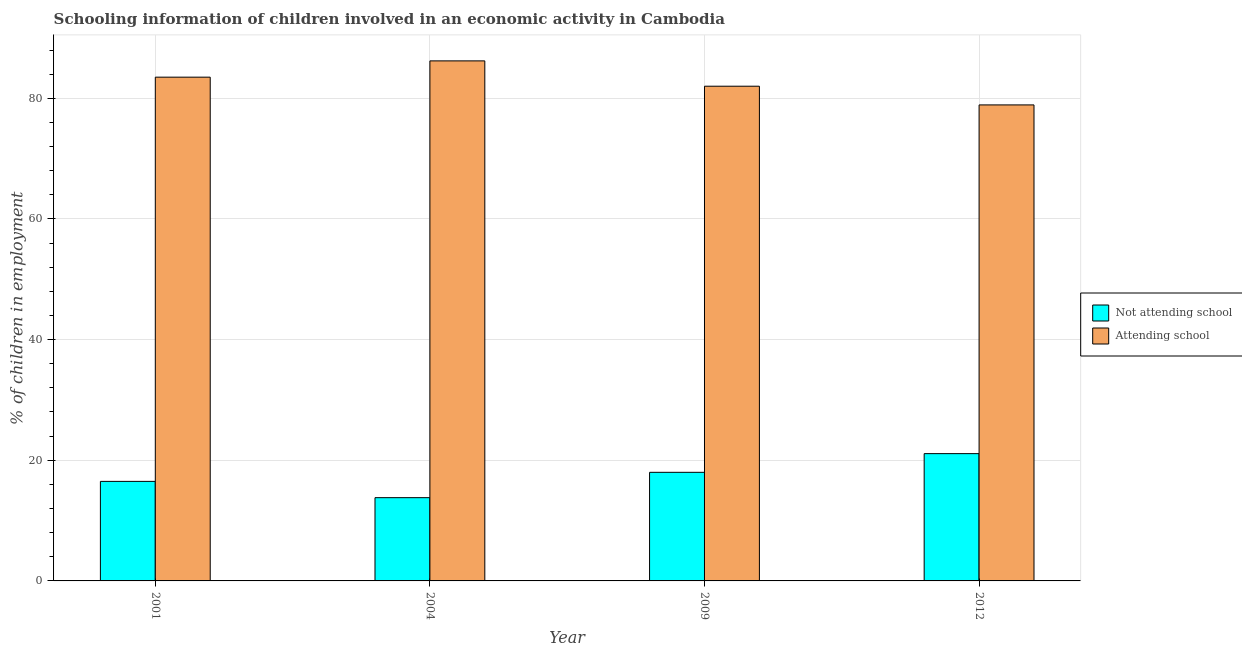How many groups of bars are there?
Make the answer very short. 4. Are the number of bars per tick equal to the number of legend labels?
Keep it short and to the point. Yes. Are the number of bars on each tick of the X-axis equal?
Give a very brief answer. Yes. What is the label of the 1st group of bars from the left?
Your response must be concise. 2001. In how many cases, is the number of bars for a given year not equal to the number of legend labels?
Your answer should be very brief. 0. What is the percentage of employed children who are not attending school in 2004?
Offer a very short reply. 13.8. Across all years, what is the maximum percentage of employed children who are attending school?
Your answer should be compact. 86.2. Across all years, what is the minimum percentage of employed children who are not attending school?
Your response must be concise. 13.8. In which year was the percentage of employed children who are attending school minimum?
Give a very brief answer. 2012. What is the total percentage of employed children who are not attending school in the graph?
Your answer should be compact. 69.4. What is the difference between the percentage of employed children who are attending school in 2001 and that in 2004?
Provide a succinct answer. -2.7. What is the difference between the percentage of employed children who are not attending school in 2001 and the percentage of employed children who are attending school in 2004?
Keep it short and to the point. 2.7. What is the average percentage of employed children who are attending school per year?
Your response must be concise. 82.65. In the year 2009, what is the difference between the percentage of employed children who are attending school and percentage of employed children who are not attending school?
Make the answer very short. 0. What is the ratio of the percentage of employed children who are not attending school in 2009 to that in 2012?
Offer a very short reply. 0.85. Is the difference between the percentage of employed children who are not attending school in 2004 and 2012 greater than the difference between the percentage of employed children who are attending school in 2004 and 2012?
Provide a short and direct response. No. What is the difference between the highest and the second highest percentage of employed children who are attending school?
Your answer should be compact. 2.7. What is the difference between the highest and the lowest percentage of employed children who are not attending school?
Your response must be concise. 7.3. In how many years, is the percentage of employed children who are attending school greater than the average percentage of employed children who are attending school taken over all years?
Your answer should be compact. 2. Is the sum of the percentage of employed children who are not attending school in 2001 and 2012 greater than the maximum percentage of employed children who are attending school across all years?
Provide a succinct answer. Yes. What does the 2nd bar from the left in 2001 represents?
Ensure brevity in your answer.  Attending school. What does the 2nd bar from the right in 2009 represents?
Your answer should be compact. Not attending school. How many bars are there?
Your answer should be very brief. 8. What is the difference between two consecutive major ticks on the Y-axis?
Your response must be concise. 20. Are the values on the major ticks of Y-axis written in scientific E-notation?
Your response must be concise. No. Does the graph contain any zero values?
Your answer should be compact. No. How many legend labels are there?
Give a very brief answer. 2. How are the legend labels stacked?
Provide a succinct answer. Vertical. What is the title of the graph?
Offer a very short reply. Schooling information of children involved in an economic activity in Cambodia. What is the label or title of the Y-axis?
Give a very brief answer. % of children in employment. What is the % of children in employment of Not attending school in 2001?
Your response must be concise. 16.5. What is the % of children in employment in Attending school in 2001?
Your answer should be compact. 83.5. What is the % of children in employment of Attending school in 2004?
Offer a very short reply. 86.2. What is the % of children in employment in Attending school in 2009?
Keep it short and to the point. 82. What is the % of children in employment of Not attending school in 2012?
Keep it short and to the point. 21.1. What is the % of children in employment of Attending school in 2012?
Your answer should be compact. 78.9. Across all years, what is the maximum % of children in employment in Not attending school?
Make the answer very short. 21.1. Across all years, what is the maximum % of children in employment of Attending school?
Offer a terse response. 86.2. Across all years, what is the minimum % of children in employment in Attending school?
Offer a very short reply. 78.9. What is the total % of children in employment in Not attending school in the graph?
Your response must be concise. 69.4. What is the total % of children in employment of Attending school in the graph?
Keep it short and to the point. 330.6. What is the difference between the % of children in employment of Not attending school in 2001 and that in 2004?
Provide a succinct answer. 2.7. What is the difference between the % of children in employment of Attending school in 2001 and that in 2004?
Your answer should be compact. -2.7. What is the difference between the % of children in employment in Not attending school in 2001 and that in 2009?
Provide a succinct answer. -1.5. What is the difference between the % of children in employment of Not attending school in 2001 and that in 2012?
Keep it short and to the point. -4.6. What is the difference between the % of children in employment in Attending school in 2004 and that in 2009?
Keep it short and to the point. 4.2. What is the difference between the % of children in employment of Not attending school in 2004 and that in 2012?
Your answer should be compact. -7.3. What is the difference between the % of children in employment of Not attending school in 2001 and the % of children in employment of Attending school in 2004?
Provide a succinct answer. -69.7. What is the difference between the % of children in employment in Not attending school in 2001 and the % of children in employment in Attending school in 2009?
Make the answer very short. -65.5. What is the difference between the % of children in employment of Not attending school in 2001 and the % of children in employment of Attending school in 2012?
Your answer should be very brief. -62.4. What is the difference between the % of children in employment in Not attending school in 2004 and the % of children in employment in Attending school in 2009?
Your answer should be very brief. -68.2. What is the difference between the % of children in employment in Not attending school in 2004 and the % of children in employment in Attending school in 2012?
Provide a succinct answer. -65.1. What is the difference between the % of children in employment in Not attending school in 2009 and the % of children in employment in Attending school in 2012?
Offer a very short reply. -60.9. What is the average % of children in employment in Not attending school per year?
Ensure brevity in your answer.  17.35. What is the average % of children in employment of Attending school per year?
Ensure brevity in your answer.  82.65. In the year 2001, what is the difference between the % of children in employment in Not attending school and % of children in employment in Attending school?
Your answer should be very brief. -67. In the year 2004, what is the difference between the % of children in employment of Not attending school and % of children in employment of Attending school?
Make the answer very short. -72.4. In the year 2009, what is the difference between the % of children in employment in Not attending school and % of children in employment in Attending school?
Keep it short and to the point. -64. In the year 2012, what is the difference between the % of children in employment of Not attending school and % of children in employment of Attending school?
Offer a very short reply. -57.8. What is the ratio of the % of children in employment in Not attending school in 2001 to that in 2004?
Offer a very short reply. 1.2. What is the ratio of the % of children in employment of Attending school in 2001 to that in 2004?
Give a very brief answer. 0.97. What is the ratio of the % of children in employment of Attending school in 2001 to that in 2009?
Give a very brief answer. 1.02. What is the ratio of the % of children in employment of Not attending school in 2001 to that in 2012?
Provide a succinct answer. 0.78. What is the ratio of the % of children in employment of Attending school in 2001 to that in 2012?
Give a very brief answer. 1.06. What is the ratio of the % of children in employment of Not attending school in 2004 to that in 2009?
Give a very brief answer. 0.77. What is the ratio of the % of children in employment in Attending school in 2004 to that in 2009?
Your answer should be very brief. 1.05. What is the ratio of the % of children in employment of Not attending school in 2004 to that in 2012?
Your answer should be very brief. 0.65. What is the ratio of the % of children in employment in Attending school in 2004 to that in 2012?
Provide a short and direct response. 1.09. What is the ratio of the % of children in employment in Not attending school in 2009 to that in 2012?
Offer a very short reply. 0.85. What is the ratio of the % of children in employment of Attending school in 2009 to that in 2012?
Keep it short and to the point. 1.04. What is the difference between the highest and the second highest % of children in employment of Attending school?
Keep it short and to the point. 2.7. What is the difference between the highest and the lowest % of children in employment of Attending school?
Give a very brief answer. 7.3. 